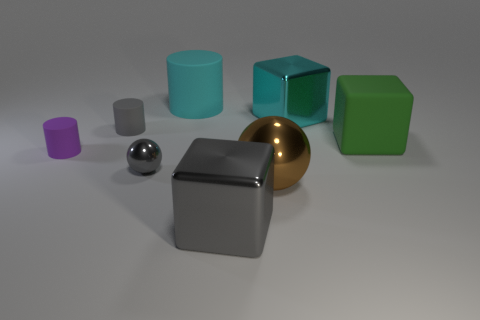What number of tiny cyan matte cubes are there?
Offer a very short reply. 0. What material is the gray object that is to the right of the sphere to the left of the large cyan matte cylinder?
Ensure brevity in your answer.  Metal. There is a matte thing behind the shiny object that is behind the rubber object in front of the large green matte block; what color is it?
Provide a short and direct response. Cyan. Is the color of the small shiny thing the same as the big cylinder?
Make the answer very short. No. What number of gray rubber objects have the same size as the cyan metal block?
Give a very brief answer. 0. Are there more metal things that are to the left of the big rubber cylinder than gray shiny objects that are on the right side of the big shiny ball?
Provide a short and direct response. Yes. What is the color of the tiny cylinder that is in front of the small rubber cylinder that is right of the small purple rubber thing?
Keep it short and to the point. Purple. Do the large gray cube and the big brown object have the same material?
Your answer should be compact. Yes. Are there any large green rubber objects that have the same shape as the large gray thing?
Your answer should be very brief. Yes. There is a shiny cube that is behind the tiny gray metallic ball; does it have the same color as the big cylinder?
Your answer should be very brief. Yes. 